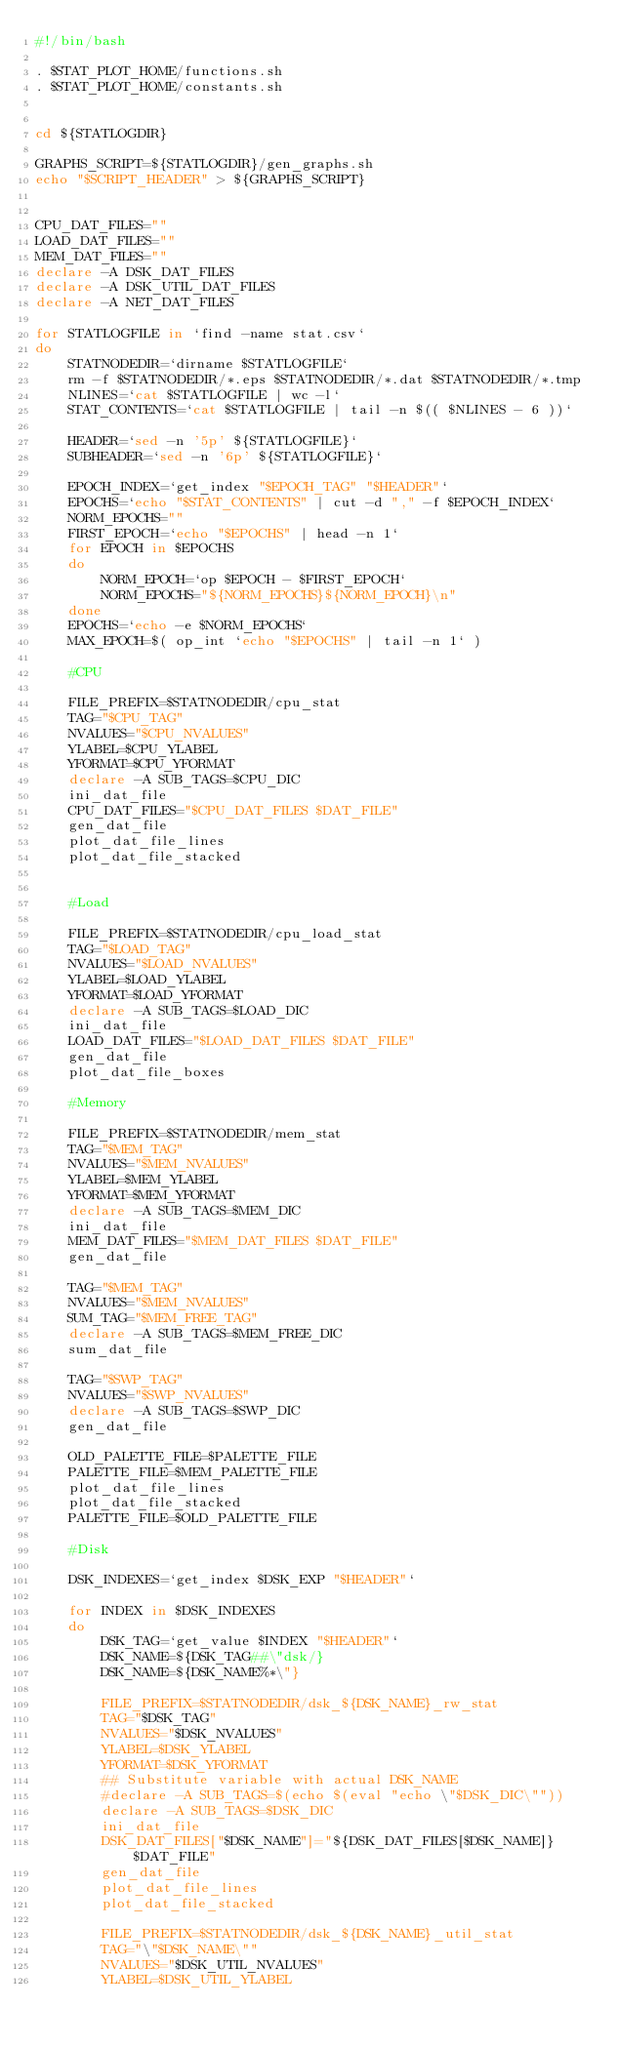<code> <loc_0><loc_0><loc_500><loc_500><_Bash_>#!/bin/bash

. $STAT_PLOT_HOME/functions.sh
. $STAT_PLOT_HOME/constants.sh


cd ${STATLOGDIR}

GRAPHS_SCRIPT=${STATLOGDIR}/gen_graphs.sh
echo "$SCRIPT_HEADER" > ${GRAPHS_SCRIPT}


CPU_DAT_FILES=""
LOAD_DAT_FILES=""
MEM_DAT_FILES=""
declare -A DSK_DAT_FILES
declare -A DSK_UTIL_DAT_FILES
declare -A NET_DAT_FILES

for STATLOGFILE in `find -name stat.csv`
do
	STATNODEDIR=`dirname $STATLOGFILE`
	rm -f $STATNODEDIR/*.eps $STATNODEDIR/*.dat $STATNODEDIR/*.tmp
	NLINES=`cat $STATLOGFILE | wc -l`
	STAT_CONTENTS=`cat $STATLOGFILE | tail -n $(( $NLINES - 6 ))`

	HEADER=`sed -n '5p' ${STATLOGFILE}`
	SUBHEADER=`sed -n '6p' ${STATLOGFILE}`

	EPOCH_INDEX=`get_index "$EPOCH_TAG" "$HEADER"`
	EPOCHS=`echo "$STAT_CONTENTS" | cut -d "," -f $EPOCH_INDEX`
	NORM_EPOCHS=""
	FIRST_EPOCH=`echo "$EPOCHS" | head -n 1`
	for EPOCH in $EPOCHS
	do
		NORM_EPOCH=`op $EPOCH - $FIRST_EPOCH`
		NORM_EPOCHS="${NORM_EPOCHS}${NORM_EPOCH}\n"
	done
	EPOCHS=`echo -e $NORM_EPOCHS`
	MAX_EPOCH=$( op_int `echo "$EPOCHS" | tail -n 1` )
	
	#CPU

	FILE_PREFIX=$STATNODEDIR/cpu_stat
	TAG="$CPU_TAG"
	NVALUES="$CPU_NVALUES"
	YLABEL=$CPU_YLABEL
	YFORMAT=$CPU_YFORMAT
	declare -A SUB_TAGS=$CPU_DIC
	ini_dat_file
	CPU_DAT_FILES="$CPU_DAT_FILES $DAT_FILE"
	gen_dat_file
	plot_dat_file_lines
	plot_dat_file_stacked
	

	#Load

	FILE_PREFIX=$STATNODEDIR/cpu_load_stat
	TAG="$LOAD_TAG"
	NVALUES="$LOAD_NVALUES"
	YLABEL=$LOAD_YLABEL
	YFORMAT=$LOAD_YFORMAT
	declare -A SUB_TAGS=$LOAD_DIC
	ini_dat_file
	LOAD_DAT_FILES="$LOAD_DAT_FILES $DAT_FILE"
	gen_dat_file
	plot_dat_file_boxes

	#Memory

	FILE_PREFIX=$STATNODEDIR/mem_stat
	TAG="$MEM_TAG"
	NVALUES="$MEM_NVALUES"
	YLABEL=$MEM_YLABEL
	YFORMAT=$MEM_YFORMAT
	declare -A SUB_TAGS=$MEM_DIC
	ini_dat_file
	MEM_DAT_FILES="$MEM_DAT_FILES $DAT_FILE"
	gen_dat_file

	TAG="$MEM_TAG"
	NVALUES="$MEM_NVALUES"
	SUM_TAG="$MEM_FREE_TAG"
	declare -A SUB_TAGS=$MEM_FREE_DIC
	sum_dat_file

	TAG="$SWP_TAG"
	NVALUES="$SWP_NVALUES"
	declare -A SUB_TAGS=$SWP_DIC
	gen_dat_file
	
	OLD_PALETTE_FILE=$PALETTE_FILE
	PALETTE_FILE=$MEM_PALETTE_FILE
	plot_dat_file_lines
	plot_dat_file_stacked
	PALETTE_FILE=$OLD_PALETTE_FILE

	#Disk

	DSK_INDEXES=`get_index $DSK_EXP "$HEADER"`

	for INDEX in $DSK_INDEXES
	do
		DSK_TAG=`get_value $INDEX "$HEADER"`
		DSK_NAME=${DSK_TAG##\"dsk/}
		DSK_NAME=${DSK_NAME%*\"}

		FILE_PREFIX=$STATNODEDIR/dsk_${DSK_NAME}_rw_stat
		TAG="$DSK_TAG"
		NVALUES="$DSK_NVALUES"
		YLABEL=$DSK_YLABEL
		YFORMAT=$DSK_YFORMAT
		## Substitute variable with actual DSK_NAME
		#declare -A SUB_TAGS=$(echo $(eval "echo \"$DSK_DIC\""))
		declare -A SUB_TAGS=$DSK_DIC
		ini_dat_file
		DSK_DAT_FILES["$DSK_NAME"]="${DSK_DAT_FILES[$DSK_NAME]} $DAT_FILE"
		gen_dat_file
		plot_dat_file_lines
		plot_dat_file_stacked

		FILE_PREFIX=$STATNODEDIR/dsk_${DSK_NAME}_util_stat
		TAG="\"$DSK_NAME\""
		NVALUES="$DSK_UTIL_NVALUES"
		YLABEL=$DSK_UTIL_YLABEL</code> 